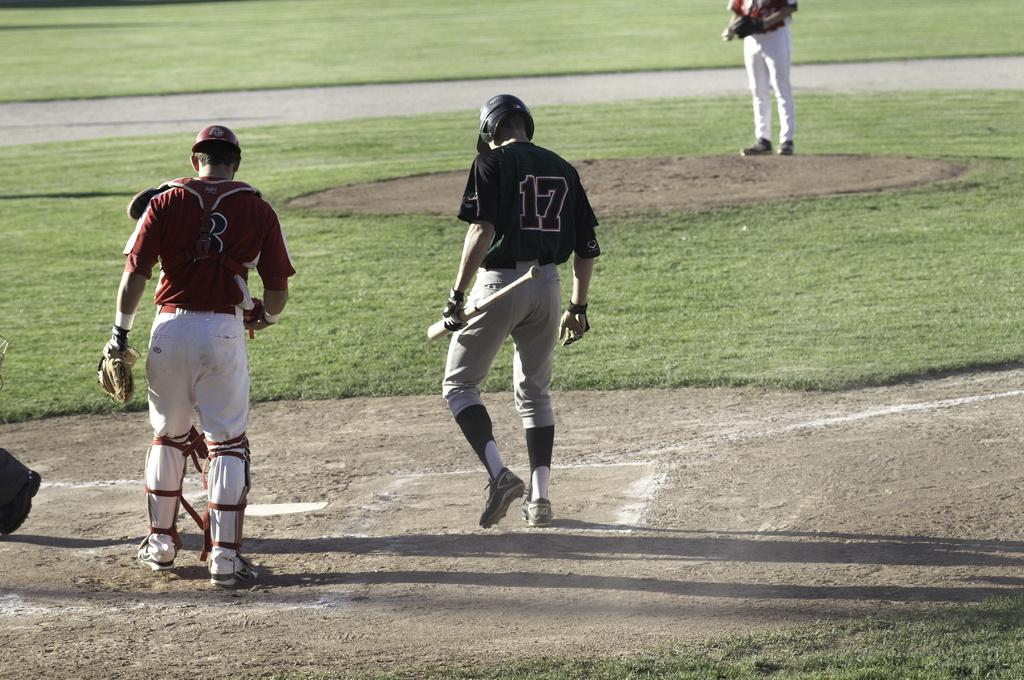<image>
Summarize the visual content of the image. A baseball player number 17 walks up to home plate during a baseball game. 